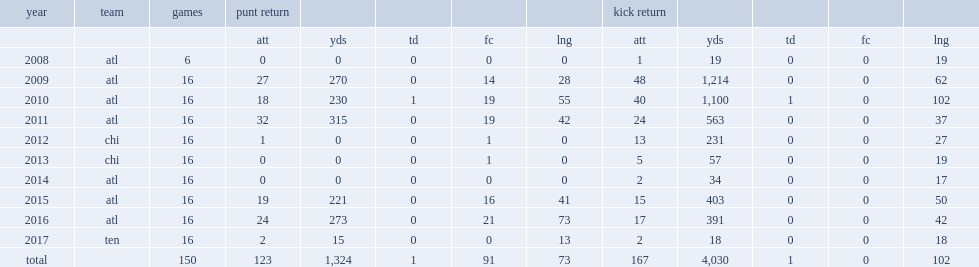What was the number of punts for yards that eric weems returned in 2015? 221.0. Could you help me parse every detail presented in this table? {'header': ['year', 'team', 'games', 'punt return', '', '', '', '', 'kick return', '', '', '', ''], 'rows': [['', '', '', 'att', 'yds', 'td', 'fc', 'lng', 'att', 'yds', 'td', 'fc', 'lng'], ['2008', 'atl', '6', '0', '0', '0', '0', '0', '1', '19', '0', '0', '19'], ['2009', 'atl', '16', '27', '270', '0', '14', '28', '48', '1,214', '0', '0', '62'], ['2010', 'atl', '16', '18', '230', '1', '19', '55', '40', '1,100', '1', '0', '102'], ['2011', 'atl', '16', '32', '315', '0', '19', '42', '24', '563', '0', '0', '37'], ['2012', 'chi', '16', '1', '0', '0', '1', '0', '13', '231', '0', '0', '27'], ['2013', 'chi', '16', '0', '0', '0', '1', '0', '5', '57', '0', '0', '19'], ['2014', 'atl', '16', '0', '0', '0', '0', '0', '2', '34', '0', '0', '17'], ['2015', 'atl', '16', '19', '221', '0', '16', '41', '15', '403', '0', '0', '50'], ['2016', 'atl', '16', '24', '273', '0', '21', '73', '17', '391', '0', '0', '42'], ['2017', 'ten', '16', '2', '15', '0', '0', '13', '2', '18', '0', '0', '18'], ['total', '', '150', '123', '1,324', '1', '91', '73', '167', '4,030', '1', '0', '102']]} 